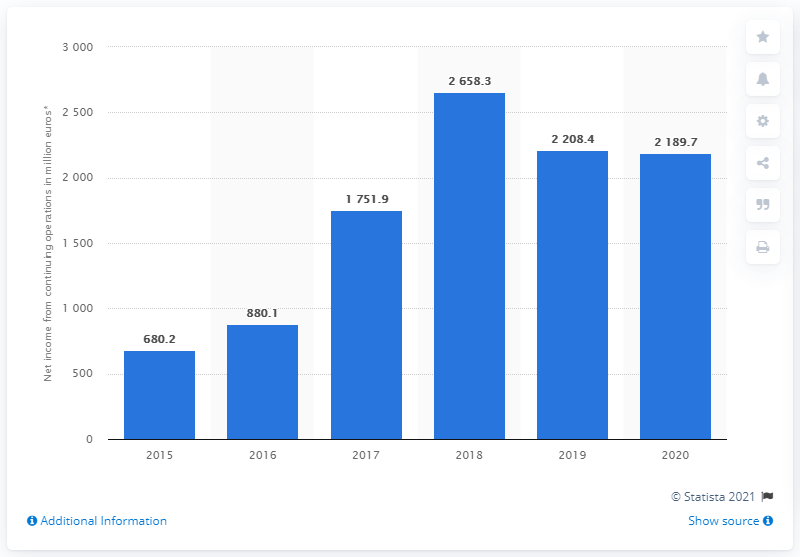Indicate a few pertinent items in this graphic. In 2020, the Kering Group's net income was 2,189.7 million euros. 